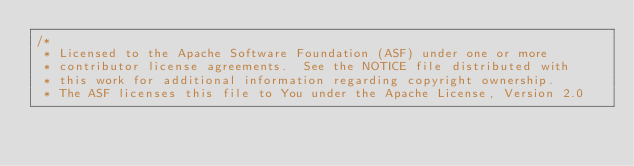Convert code to text. <code><loc_0><loc_0><loc_500><loc_500><_Java_>/*
 * Licensed to the Apache Software Foundation (ASF) under one or more
 * contributor license agreements.  See the NOTICE file distributed with
 * this work for additional information regarding copyright ownership.
 * The ASF licenses this file to You under the Apache License, Version 2.0</code> 